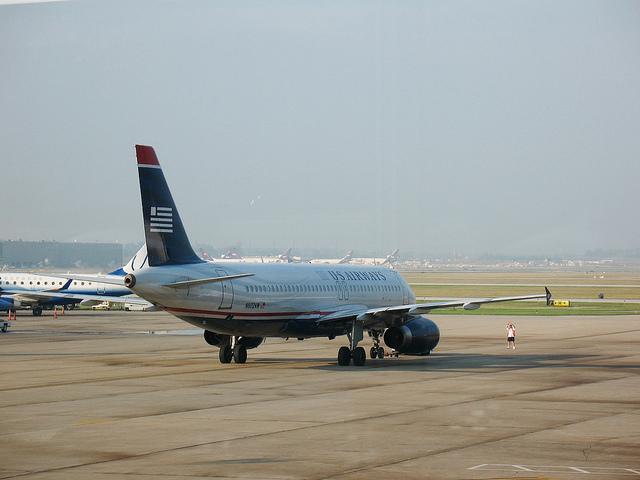What color is the tail fin of this airplane?
Short answer required. Blue. Is anyone walking near the plane?
Answer briefly. Yes. Has the plane just landed?
Quick response, please. Yes. 